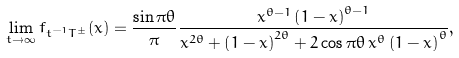<formula> <loc_0><loc_0><loc_500><loc_500>\lim _ { t \rightarrow \infty } f _ { t ^ { - 1 } T ^ { \pm } } ( x ) = \frac { \sin \pi \theta } { \pi } \frac { x ^ { \theta - 1 } \left ( 1 - x \right ) ^ { \theta - 1 } } { x ^ { 2 \theta } + \left ( 1 - x \right ) ^ { 2 \theta } + 2 \cos \pi \theta \, x ^ { \theta } \left ( 1 - x \right ) ^ { \theta } } ,</formula> 